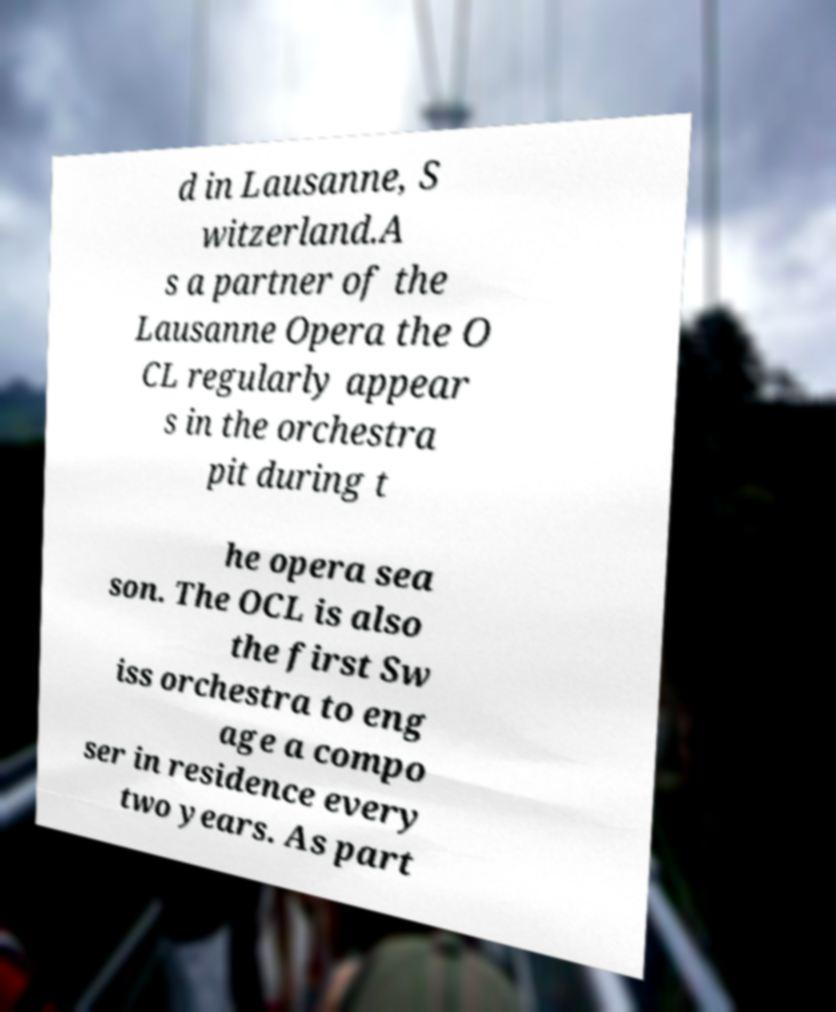For documentation purposes, I need the text within this image transcribed. Could you provide that? d in Lausanne, S witzerland.A s a partner of the Lausanne Opera the O CL regularly appear s in the orchestra pit during t he opera sea son. The OCL is also the first Sw iss orchestra to eng age a compo ser in residence every two years. As part 